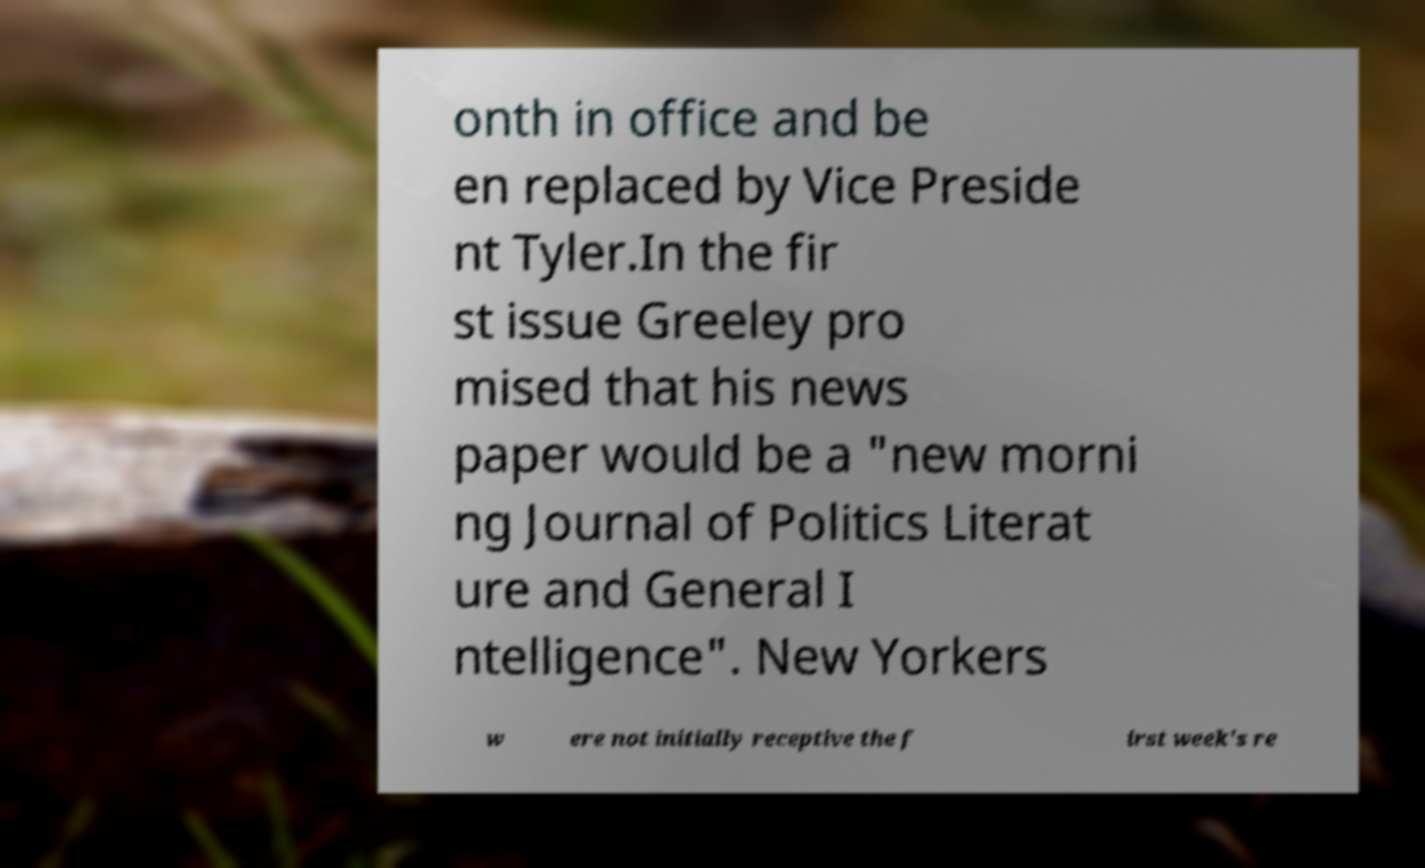For documentation purposes, I need the text within this image transcribed. Could you provide that? onth in office and be en replaced by Vice Preside nt Tyler.In the fir st issue Greeley pro mised that his news paper would be a "new morni ng Journal of Politics Literat ure and General I ntelligence". New Yorkers w ere not initially receptive the f irst week's re 